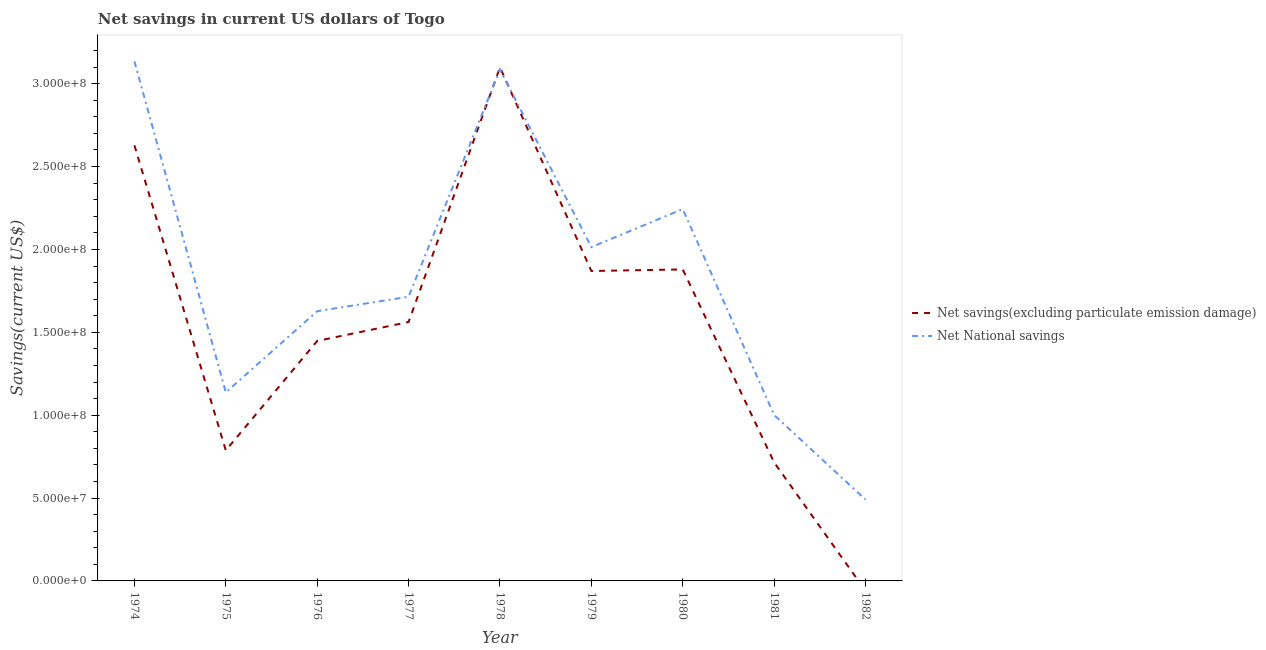What is the net national savings in 1976?
Ensure brevity in your answer.  1.63e+08. Across all years, what is the maximum net national savings?
Keep it short and to the point. 3.13e+08. Across all years, what is the minimum net savings(excluding particulate emission damage)?
Provide a succinct answer. 0. In which year was the net national savings maximum?
Offer a terse response. 1974. What is the total net national savings in the graph?
Your answer should be very brief. 1.64e+09. What is the difference between the net savings(excluding particulate emission damage) in 1974 and that in 1977?
Give a very brief answer. 1.07e+08. What is the difference between the net national savings in 1980 and the net savings(excluding particulate emission damage) in 1977?
Provide a succinct answer. 6.81e+07. What is the average net savings(excluding particulate emission damage) per year?
Provide a short and direct response. 1.55e+08. In the year 1974, what is the difference between the net savings(excluding particulate emission damage) and net national savings?
Your response must be concise. -5.07e+07. What is the ratio of the net national savings in 1976 to that in 1977?
Provide a short and direct response. 0.95. Is the net national savings in 1976 less than that in 1977?
Your response must be concise. Yes. What is the difference between the highest and the second highest net savings(excluding particulate emission damage)?
Your answer should be compact. 4.70e+07. What is the difference between the highest and the lowest net savings(excluding particulate emission damage)?
Provide a succinct answer. 3.10e+08. In how many years, is the net savings(excluding particulate emission damage) greater than the average net savings(excluding particulate emission damage) taken over all years?
Give a very brief answer. 5. Does the net national savings monotonically increase over the years?
Your response must be concise. No. Is the net national savings strictly greater than the net savings(excluding particulate emission damage) over the years?
Keep it short and to the point. No. How many lines are there?
Make the answer very short. 2. Are the values on the major ticks of Y-axis written in scientific E-notation?
Your answer should be very brief. Yes. Does the graph contain grids?
Offer a very short reply. No. How many legend labels are there?
Your answer should be compact. 2. How are the legend labels stacked?
Your answer should be very brief. Vertical. What is the title of the graph?
Offer a terse response. Net savings in current US dollars of Togo. Does "Mineral" appear as one of the legend labels in the graph?
Make the answer very short. No. What is the label or title of the X-axis?
Provide a short and direct response. Year. What is the label or title of the Y-axis?
Provide a succinct answer. Savings(current US$). What is the Savings(current US$) of Net savings(excluding particulate emission damage) in 1974?
Make the answer very short. 2.63e+08. What is the Savings(current US$) in Net National savings in 1974?
Ensure brevity in your answer.  3.13e+08. What is the Savings(current US$) in Net savings(excluding particulate emission damage) in 1975?
Make the answer very short. 7.87e+07. What is the Savings(current US$) in Net National savings in 1975?
Your answer should be very brief. 1.14e+08. What is the Savings(current US$) in Net savings(excluding particulate emission damage) in 1976?
Make the answer very short. 1.45e+08. What is the Savings(current US$) of Net National savings in 1976?
Your answer should be very brief. 1.63e+08. What is the Savings(current US$) of Net savings(excluding particulate emission damage) in 1977?
Make the answer very short. 1.56e+08. What is the Savings(current US$) in Net National savings in 1977?
Offer a very short reply. 1.71e+08. What is the Savings(current US$) in Net savings(excluding particulate emission damage) in 1978?
Provide a succinct answer. 3.10e+08. What is the Savings(current US$) of Net National savings in 1978?
Provide a succinct answer. 3.09e+08. What is the Savings(current US$) of Net savings(excluding particulate emission damage) in 1979?
Your answer should be very brief. 1.87e+08. What is the Savings(current US$) of Net National savings in 1979?
Provide a short and direct response. 2.01e+08. What is the Savings(current US$) of Net savings(excluding particulate emission damage) in 1980?
Your answer should be very brief. 1.88e+08. What is the Savings(current US$) of Net National savings in 1980?
Keep it short and to the point. 2.24e+08. What is the Savings(current US$) in Net savings(excluding particulate emission damage) in 1981?
Offer a terse response. 7.15e+07. What is the Savings(current US$) of Net National savings in 1981?
Your answer should be very brief. 1.00e+08. What is the Savings(current US$) in Net National savings in 1982?
Your answer should be compact. 4.91e+07. Across all years, what is the maximum Savings(current US$) in Net savings(excluding particulate emission damage)?
Keep it short and to the point. 3.10e+08. Across all years, what is the maximum Savings(current US$) of Net National savings?
Give a very brief answer. 3.13e+08. Across all years, what is the minimum Savings(current US$) of Net National savings?
Provide a short and direct response. 4.91e+07. What is the total Savings(current US$) in Net savings(excluding particulate emission damage) in the graph?
Your answer should be very brief. 1.40e+09. What is the total Savings(current US$) of Net National savings in the graph?
Provide a short and direct response. 1.64e+09. What is the difference between the Savings(current US$) in Net savings(excluding particulate emission damage) in 1974 and that in 1975?
Provide a succinct answer. 1.84e+08. What is the difference between the Savings(current US$) in Net National savings in 1974 and that in 1975?
Ensure brevity in your answer.  2.00e+08. What is the difference between the Savings(current US$) in Net savings(excluding particulate emission damage) in 1974 and that in 1976?
Offer a terse response. 1.18e+08. What is the difference between the Savings(current US$) in Net National savings in 1974 and that in 1976?
Offer a very short reply. 1.51e+08. What is the difference between the Savings(current US$) in Net savings(excluding particulate emission damage) in 1974 and that in 1977?
Offer a terse response. 1.07e+08. What is the difference between the Savings(current US$) of Net National savings in 1974 and that in 1977?
Your answer should be very brief. 1.42e+08. What is the difference between the Savings(current US$) in Net savings(excluding particulate emission damage) in 1974 and that in 1978?
Your response must be concise. -4.70e+07. What is the difference between the Savings(current US$) of Net National savings in 1974 and that in 1978?
Provide a succinct answer. 4.97e+06. What is the difference between the Savings(current US$) of Net savings(excluding particulate emission damage) in 1974 and that in 1979?
Your answer should be very brief. 7.58e+07. What is the difference between the Savings(current US$) in Net National savings in 1974 and that in 1979?
Provide a short and direct response. 1.12e+08. What is the difference between the Savings(current US$) in Net savings(excluding particulate emission damage) in 1974 and that in 1980?
Offer a very short reply. 7.49e+07. What is the difference between the Savings(current US$) in Net National savings in 1974 and that in 1980?
Ensure brevity in your answer.  8.91e+07. What is the difference between the Savings(current US$) of Net savings(excluding particulate emission damage) in 1974 and that in 1981?
Your response must be concise. 1.91e+08. What is the difference between the Savings(current US$) in Net National savings in 1974 and that in 1981?
Offer a very short reply. 2.13e+08. What is the difference between the Savings(current US$) of Net National savings in 1974 and that in 1982?
Your answer should be compact. 2.64e+08. What is the difference between the Savings(current US$) in Net savings(excluding particulate emission damage) in 1975 and that in 1976?
Keep it short and to the point. -6.61e+07. What is the difference between the Savings(current US$) of Net National savings in 1975 and that in 1976?
Your answer should be very brief. -4.90e+07. What is the difference between the Savings(current US$) of Net savings(excluding particulate emission damage) in 1975 and that in 1977?
Your answer should be very brief. -7.75e+07. What is the difference between the Savings(current US$) of Net National savings in 1975 and that in 1977?
Offer a terse response. -5.77e+07. What is the difference between the Savings(current US$) in Net savings(excluding particulate emission damage) in 1975 and that in 1978?
Give a very brief answer. -2.31e+08. What is the difference between the Savings(current US$) in Net National savings in 1975 and that in 1978?
Offer a very short reply. -1.95e+08. What is the difference between the Savings(current US$) in Net savings(excluding particulate emission damage) in 1975 and that in 1979?
Offer a terse response. -1.08e+08. What is the difference between the Savings(current US$) of Net National savings in 1975 and that in 1979?
Your answer should be very brief. -8.77e+07. What is the difference between the Savings(current US$) in Net savings(excluding particulate emission damage) in 1975 and that in 1980?
Your response must be concise. -1.09e+08. What is the difference between the Savings(current US$) in Net National savings in 1975 and that in 1980?
Offer a terse response. -1.11e+08. What is the difference between the Savings(current US$) of Net savings(excluding particulate emission damage) in 1975 and that in 1981?
Your answer should be very brief. 7.24e+06. What is the difference between the Savings(current US$) in Net National savings in 1975 and that in 1981?
Make the answer very short. 1.36e+07. What is the difference between the Savings(current US$) of Net National savings in 1975 and that in 1982?
Make the answer very short. 6.47e+07. What is the difference between the Savings(current US$) in Net savings(excluding particulate emission damage) in 1976 and that in 1977?
Offer a terse response. -1.14e+07. What is the difference between the Savings(current US$) of Net National savings in 1976 and that in 1977?
Provide a short and direct response. -8.74e+06. What is the difference between the Savings(current US$) in Net savings(excluding particulate emission damage) in 1976 and that in 1978?
Keep it short and to the point. -1.65e+08. What is the difference between the Savings(current US$) of Net National savings in 1976 and that in 1978?
Keep it short and to the point. -1.46e+08. What is the difference between the Savings(current US$) in Net savings(excluding particulate emission damage) in 1976 and that in 1979?
Give a very brief answer. -4.22e+07. What is the difference between the Savings(current US$) in Net National savings in 1976 and that in 1979?
Your answer should be compact. -3.87e+07. What is the difference between the Savings(current US$) in Net savings(excluding particulate emission damage) in 1976 and that in 1980?
Provide a short and direct response. -4.31e+07. What is the difference between the Savings(current US$) of Net National savings in 1976 and that in 1980?
Make the answer very short. -6.16e+07. What is the difference between the Savings(current US$) in Net savings(excluding particulate emission damage) in 1976 and that in 1981?
Offer a terse response. 7.33e+07. What is the difference between the Savings(current US$) of Net National savings in 1976 and that in 1981?
Keep it short and to the point. 6.26e+07. What is the difference between the Savings(current US$) of Net National savings in 1976 and that in 1982?
Provide a succinct answer. 1.14e+08. What is the difference between the Savings(current US$) of Net savings(excluding particulate emission damage) in 1977 and that in 1978?
Offer a terse response. -1.54e+08. What is the difference between the Savings(current US$) in Net National savings in 1977 and that in 1978?
Offer a terse response. -1.37e+08. What is the difference between the Savings(current US$) of Net savings(excluding particulate emission damage) in 1977 and that in 1979?
Provide a short and direct response. -3.08e+07. What is the difference between the Savings(current US$) of Net National savings in 1977 and that in 1979?
Provide a succinct answer. -2.99e+07. What is the difference between the Savings(current US$) of Net savings(excluding particulate emission damage) in 1977 and that in 1980?
Keep it short and to the point. -3.17e+07. What is the difference between the Savings(current US$) of Net National savings in 1977 and that in 1980?
Keep it short and to the point. -5.29e+07. What is the difference between the Savings(current US$) of Net savings(excluding particulate emission damage) in 1977 and that in 1981?
Offer a terse response. 8.47e+07. What is the difference between the Savings(current US$) of Net National savings in 1977 and that in 1981?
Make the answer very short. 7.14e+07. What is the difference between the Savings(current US$) of Net National savings in 1977 and that in 1982?
Offer a very short reply. 1.22e+08. What is the difference between the Savings(current US$) in Net savings(excluding particulate emission damage) in 1978 and that in 1979?
Keep it short and to the point. 1.23e+08. What is the difference between the Savings(current US$) of Net National savings in 1978 and that in 1979?
Your answer should be compact. 1.07e+08. What is the difference between the Savings(current US$) of Net savings(excluding particulate emission damage) in 1978 and that in 1980?
Provide a succinct answer. 1.22e+08. What is the difference between the Savings(current US$) in Net National savings in 1978 and that in 1980?
Make the answer very short. 8.42e+07. What is the difference between the Savings(current US$) in Net savings(excluding particulate emission damage) in 1978 and that in 1981?
Give a very brief answer. 2.38e+08. What is the difference between the Savings(current US$) in Net National savings in 1978 and that in 1981?
Keep it short and to the point. 2.08e+08. What is the difference between the Savings(current US$) in Net National savings in 1978 and that in 1982?
Offer a very short reply. 2.59e+08. What is the difference between the Savings(current US$) of Net savings(excluding particulate emission damage) in 1979 and that in 1980?
Your answer should be compact. -9.44e+05. What is the difference between the Savings(current US$) in Net National savings in 1979 and that in 1980?
Your response must be concise. -2.29e+07. What is the difference between the Savings(current US$) of Net savings(excluding particulate emission damage) in 1979 and that in 1981?
Offer a terse response. 1.15e+08. What is the difference between the Savings(current US$) in Net National savings in 1979 and that in 1981?
Ensure brevity in your answer.  1.01e+08. What is the difference between the Savings(current US$) in Net National savings in 1979 and that in 1982?
Keep it short and to the point. 1.52e+08. What is the difference between the Savings(current US$) of Net savings(excluding particulate emission damage) in 1980 and that in 1981?
Provide a succinct answer. 1.16e+08. What is the difference between the Savings(current US$) of Net National savings in 1980 and that in 1981?
Provide a succinct answer. 1.24e+08. What is the difference between the Savings(current US$) in Net National savings in 1980 and that in 1982?
Your answer should be very brief. 1.75e+08. What is the difference between the Savings(current US$) in Net National savings in 1981 and that in 1982?
Ensure brevity in your answer.  5.10e+07. What is the difference between the Savings(current US$) of Net savings(excluding particulate emission damage) in 1974 and the Savings(current US$) of Net National savings in 1975?
Give a very brief answer. 1.49e+08. What is the difference between the Savings(current US$) in Net savings(excluding particulate emission damage) in 1974 and the Savings(current US$) in Net National savings in 1976?
Give a very brief answer. 1.00e+08. What is the difference between the Savings(current US$) in Net savings(excluding particulate emission damage) in 1974 and the Savings(current US$) in Net National savings in 1977?
Your answer should be very brief. 9.13e+07. What is the difference between the Savings(current US$) of Net savings(excluding particulate emission damage) in 1974 and the Savings(current US$) of Net National savings in 1978?
Offer a very short reply. -4.57e+07. What is the difference between the Savings(current US$) in Net savings(excluding particulate emission damage) in 1974 and the Savings(current US$) in Net National savings in 1979?
Your answer should be very brief. 6.14e+07. What is the difference between the Savings(current US$) in Net savings(excluding particulate emission damage) in 1974 and the Savings(current US$) in Net National savings in 1980?
Make the answer very short. 3.85e+07. What is the difference between the Savings(current US$) of Net savings(excluding particulate emission damage) in 1974 and the Savings(current US$) of Net National savings in 1981?
Keep it short and to the point. 1.63e+08. What is the difference between the Savings(current US$) in Net savings(excluding particulate emission damage) in 1974 and the Savings(current US$) in Net National savings in 1982?
Provide a succinct answer. 2.14e+08. What is the difference between the Savings(current US$) of Net savings(excluding particulate emission damage) in 1975 and the Savings(current US$) of Net National savings in 1976?
Your answer should be compact. -8.40e+07. What is the difference between the Savings(current US$) of Net savings(excluding particulate emission damage) in 1975 and the Savings(current US$) of Net National savings in 1977?
Make the answer very short. -9.27e+07. What is the difference between the Savings(current US$) in Net savings(excluding particulate emission damage) in 1975 and the Savings(current US$) in Net National savings in 1978?
Your answer should be very brief. -2.30e+08. What is the difference between the Savings(current US$) in Net savings(excluding particulate emission damage) in 1975 and the Savings(current US$) in Net National savings in 1979?
Offer a terse response. -1.23e+08. What is the difference between the Savings(current US$) of Net savings(excluding particulate emission damage) in 1975 and the Savings(current US$) of Net National savings in 1980?
Offer a terse response. -1.46e+08. What is the difference between the Savings(current US$) in Net savings(excluding particulate emission damage) in 1975 and the Savings(current US$) in Net National savings in 1981?
Offer a terse response. -2.14e+07. What is the difference between the Savings(current US$) of Net savings(excluding particulate emission damage) in 1975 and the Savings(current US$) of Net National savings in 1982?
Give a very brief answer. 2.97e+07. What is the difference between the Savings(current US$) in Net savings(excluding particulate emission damage) in 1976 and the Savings(current US$) in Net National savings in 1977?
Your answer should be very brief. -2.67e+07. What is the difference between the Savings(current US$) in Net savings(excluding particulate emission damage) in 1976 and the Savings(current US$) in Net National savings in 1978?
Offer a very short reply. -1.64e+08. What is the difference between the Savings(current US$) of Net savings(excluding particulate emission damage) in 1976 and the Savings(current US$) of Net National savings in 1979?
Offer a very short reply. -5.66e+07. What is the difference between the Savings(current US$) of Net savings(excluding particulate emission damage) in 1976 and the Savings(current US$) of Net National savings in 1980?
Your answer should be very brief. -7.95e+07. What is the difference between the Savings(current US$) in Net savings(excluding particulate emission damage) in 1976 and the Savings(current US$) in Net National savings in 1981?
Your answer should be compact. 4.47e+07. What is the difference between the Savings(current US$) in Net savings(excluding particulate emission damage) in 1976 and the Savings(current US$) in Net National savings in 1982?
Provide a short and direct response. 9.57e+07. What is the difference between the Savings(current US$) in Net savings(excluding particulate emission damage) in 1977 and the Savings(current US$) in Net National savings in 1978?
Make the answer very short. -1.52e+08. What is the difference between the Savings(current US$) of Net savings(excluding particulate emission damage) in 1977 and the Savings(current US$) of Net National savings in 1979?
Your answer should be very brief. -4.52e+07. What is the difference between the Savings(current US$) in Net savings(excluding particulate emission damage) in 1977 and the Savings(current US$) in Net National savings in 1980?
Offer a terse response. -6.81e+07. What is the difference between the Savings(current US$) in Net savings(excluding particulate emission damage) in 1977 and the Savings(current US$) in Net National savings in 1981?
Your response must be concise. 5.61e+07. What is the difference between the Savings(current US$) in Net savings(excluding particulate emission damage) in 1977 and the Savings(current US$) in Net National savings in 1982?
Your response must be concise. 1.07e+08. What is the difference between the Savings(current US$) of Net savings(excluding particulate emission damage) in 1978 and the Savings(current US$) of Net National savings in 1979?
Keep it short and to the point. 1.08e+08. What is the difference between the Savings(current US$) in Net savings(excluding particulate emission damage) in 1978 and the Savings(current US$) in Net National savings in 1980?
Make the answer very short. 8.55e+07. What is the difference between the Savings(current US$) in Net savings(excluding particulate emission damage) in 1978 and the Savings(current US$) in Net National savings in 1981?
Offer a terse response. 2.10e+08. What is the difference between the Savings(current US$) of Net savings(excluding particulate emission damage) in 1978 and the Savings(current US$) of Net National savings in 1982?
Provide a succinct answer. 2.61e+08. What is the difference between the Savings(current US$) of Net savings(excluding particulate emission damage) in 1979 and the Savings(current US$) of Net National savings in 1980?
Give a very brief answer. -3.73e+07. What is the difference between the Savings(current US$) in Net savings(excluding particulate emission damage) in 1979 and the Savings(current US$) in Net National savings in 1981?
Ensure brevity in your answer.  8.69e+07. What is the difference between the Savings(current US$) in Net savings(excluding particulate emission damage) in 1979 and the Savings(current US$) in Net National savings in 1982?
Provide a succinct answer. 1.38e+08. What is the difference between the Savings(current US$) of Net savings(excluding particulate emission damage) in 1980 and the Savings(current US$) of Net National savings in 1981?
Offer a terse response. 8.78e+07. What is the difference between the Savings(current US$) in Net savings(excluding particulate emission damage) in 1980 and the Savings(current US$) in Net National savings in 1982?
Ensure brevity in your answer.  1.39e+08. What is the difference between the Savings(current US$) in Net savings(excluding particulate emission damage) in 1981 and the Savings(current US$) in Net National savings in 1982?
Give a very brief answer. 2.24e+07. What is the average Savings(current US$) in Net savings(excluding particulate emission damage) per year?
Give a very brief answer. 1.55e+08. What is the average Savings(current US$) of Net National savings per year?
Make the answer very short. 1.83e+08. In the year 1974, what is the difference between the Savings(current US$) of Net savings(excluding particulate emission damage) and Savings(current US$) of Net National savings?
Give a very brief answer. -5.07e+07. In the year 1975, what is the difference between the Savings(current US$) of Net savings(excluding particulate emission damage) and Savings(current US$) of Net National savings?
Your response must be concise. -3.50e+07. In the year 1976, what is the difference between the Savings(current US$) of Net savings(excluding particulate emission damage) and Savings(current US$) of Net National savings?
Give a very brief answer. -1.79e+07. In the year 1977, what is the difference between the Savings(current US$) of Net savings(excluding particulate emission damage) and Savings(current US$) of Net National savings?
Offer a very short reply. -1.53e+07. In the year 1978, what is the difference between the Savings(current US$) in Net savings(excluding particulate emission damage) and Savings(current US$) in Net National savings?
Provide a short and direct response. 1.35e+06. In the year 1979, what is the difference between the Savings(current US$) of Net savings(excluding particulate emission damage) and Savings(current US$) of Net National savings?
Your response must be concise. -1.44e+07. In the year 1980, what is the difference between the Savings(current US$) in Net savings(excluding particulate emission damage) and Savings(current US$) in Net National savings?
Offer a terse response. -3.64e+07. In the year 1981, what is the difference between the Savings(current US$) in Net savings(excluding particulate emission damage) and Savings(current US$) in Net National savings?
Your response must be concise. -2.86e+07. What is the ratio of the Savings(current US$) in Net savings(excluding particulate emission damage) in 1974 to that in 1975?
Ensure brevity in your answer.  3.34. What is the ratio of the Savings(current US$) of Net National savings in 1974 to that in 1975?
Your response must be concise. 2.76. What is the ratio of the Savings(current US$) in Net savings(excluding particulate emission damage) in 1974 to that in 1976?
Offer a terse response. 1.82. What is the ratio of the Savings(current US$) of Net National savings in 1974 to that in 1976?
Provide a succinct answer. 1.93. What is the ratio of the Savings(current US$) in Net savings(excluding particulate emission damage) in 1974 to that in 1977?
Offer a terse response. 1.68. What is the ratio of the Savings(current US$) in Net National savings in 1974 to that in 1977?
Your answer should be compact. 1.83. What is the ratio of the Savings(current US$) of Net savings(excluding particulate emission damage) in 1974 to that in 1978?
Offer a terse response. 0.85. What is the ratio of the Savings(current US$) of Net National savings in 1974 to that in 1978?
Offer a terse response. 1.02. What is the ratio of the Savings(current US$) of Net savings(excluding particulate emission damage) in 1974 to that in 1979?
Your answer should be very brief. 1.41. What is the ratio of the Savings(current US$) in Net National savings in 1974 to that in 1979?
Provide a short and direct response. 1.56. What is the ratio of the Savings(current US$) of Net savings(excluding particulate emission damage) in 1974 to that in 1980?
Ensure brevity in your answer.  1.4. What is the ratio of the Savings(current US$) of Net National savings in 1974 to that in 1980?
Make the answer very short. 1.4. What is the ratio of the Savings(current US$) in Net savings(excluding particulate emission damage) in 1974 to that in 1981?
Provide a succinct answer. 3.68. What is the ratio of the Savings(current US$) in Net National savings in 1974 to that in 1981?
Provide a short and direct response. 3.13. What is the ratio of the Savings(current US$) of Net National savings in 1974 to that in 1982?
Give a very brief answer. 6.39. What is the ratio of the Savings(current US$) of Net savings(excluding particulate emission damage) in 1975 to that in 1976?
Keep it short and to the point. 0.54. What is the ratio of the Savings(current US$) of Net National savings in 1975 to that in 1976?
Your response must be concise. 0.7. What is the ratio of the Savings(current US$) in Net savings(excluding particulate emission damage) in 1975 to that in 1977?
Ensure brevity in your answer.  0.5. What is the ratio of the Savings(current US$) in Net National savings in 1975 to that in 1977?
Your answer should be compact. 0.66. What is the ratio of the Savings(current US$) of Net savings(excluding particulate emission damage) in 1975 to that in 1978?
Your answer should be very brief. 0.25. What is the ratio of the Savings(current US$) in Net National savings in 1975 to that in 1978?
Your response must be concise. 0.37. What is the ratio of the Savings(current US$) in Net savings(excluding particulate emission damage) in 1975 to that in 1979?
Give a very brief answer. 0.42. What is the ratio of the Savings(current US$) in Net National savings in 1975 to that in 1979?
Provide a succinct answer. 0.56. What is the ratio of the Savings(current US$) in Net savings(excluding particulate emission damage) in 1975 to that in 1980?
Give a very brief answer. 0.42. What is the ratio of the Savings(current US$) of Net National savings in 1975 to that in 1980?
Your response must be concise. 0.51. What is the ratio of the Savings(current US$) in Net savings(excluding particulate emission damage) in 1975 to that in 1981?
Your answer should be very brief. 1.1. What is the ratio of the Savings(current US$) in Net National savings in 1975 to that in 1981?
Keep it short and to the point. 1.14. What is the ratio of the Savings(current US$) in Net National savings in 1975 to that in 1982?
Give a very brief answer. 2.32. What is the ratio of the Savings(current US$) of Net savings(excluding particulate emission damage) in 1976 to that in 1977?
Provide a short and direct response. 0.93. What is the ratio of the Savings(current US$) of Net National savings in 1976 to that in 1977?
Your answer should be compact. 0.95. What is the ratio of the Savings(current US$) of Net savings(excluding particulate emission damage) in 1976 to that in 1978?
Your answer should be very brief. 0.47. What is the ratio of the Savings(current US$) of Net National savings in 1976 to that in 1978?
Provide a short and direct response. 0.53. What is the ratio of the Savings(current US$) in Net savings(excluding particulate emission damage) in 1976 to that in 1979?
Provide a succinct answer. 0.77. What is the ratio of the Savings(current US$) of Net National savings in 1976 to that in 1979?
Your answer should be very brief. 0.81. What is the ratio of the Savings(current US$) of Net savings(excluding particulate emission damage) in 1976 to that in 1980?
Provide a succinct answer. 0.77. What is the ratio of the Savings(current US$) of Net National savings in 1976 to that in 1980?
Your answer should be very brief. 0.73. What is the ratio of the Savings(current US$) of Net savings(excluding particulate emission damage) in 1976 to that in 1981?
Your response must be concise. 2.03. What is the ratio of the Savings(current US$) in Net National savings in 1976 to that in 1981?
Your answer should be compact. 1.63. What is the ratio of the Savings(current US$) of Net National savings in 1976 to that in 1982?
Ensure brevity in your answer.  3.32. What is the ratio of the Savings(current US$) in Net savings(excluding particulate emission damage) in 1977 to that in 1978?
Ensure brevity in your answer.  0.5. What is the ratio of the Savings(current US$) of Net National savings in 1977 to that in 1978?
Ensure brevity in your answer.  0.56. What is the ratio of the Savings(current US$) in Net savings(excluding particulate emission damage) in 1977 to that in 1979?
Offer a terse response. 0.84. What is the ratio of the Savings(current US$) of Net National savings in 1977 to that in 1979?
Provide a succinct answer. 0.85. What is the ratio of the Savings(current US$) in Net savings(excluding particulate emission damage) in 1977 to that in 1980?
Offer a terse response. 0.83. What is the ratio of the Savings(current US$) of Net National savings in 1977 to that in 1980?
Offer a terse response. 0.76. What is the ratio of the Savings(current US$) in Net savings(excluding particulate emission damage) in 1977 to that in 1981?
Give a very brief answer. 2.18. What is the ratio of the Savings(current US$) of Net National savings in 1977 to that in 1981?
Your response must be concise. 1.71. What is the ratio of the Savings(current US$) in Net National savings in 1977 to that in 1982?
Your answer should be compact. 3.5. What is the ratio of the Savings(current US$) of Net savings(excluding particulate emission damage) in 1978 to that in 1979?
Ensure brevity in your answer.  1.66. What is the ratio of the Savings(current US$) of Net National savings in 1978 to that in 1979?
Offer a terse response. 1.53. What is the ratio of the Savings(current US$) in Net savings(excluding particulate emission damage) in 1978 to that in 1980?
Keep it short and to the point. 1.65. What is the ratio of the Savings(current US$) in Net National savings in 1978 to that in 1980?
Offer a terse response. 1.38. What is the ratio of the Savings(current US$) of Net savings(excluding particulate emission damage) in 1978 to that in 1981?
Your answer should be very brief. 4.33. What is the ratio of the Savings(current US$) of Net National savings in 1978 to that in 1981?
Give a very brief answer. 3.08. What is the ratio of the Savings(current US$) of Net National savings in 1978 to that in 1982?
Keep it short and to the point. 6.29. What is the ratio of the Savings(current US$) of Net savings(excluding particulate emission damage) in 1979 to that in 1980?
Provide a succinct answer. 0.99. What is the ratio of the Savings(current US$) in Net National savings in 1979 to that in 1980?
Make the answer very short. 0.9. What is the ratio of the Savings(current US$) in Net savings(excluding particulate emission damage) in 1979 to that in 1981?
Provide a short and direct response. 2.62. What is the ratio of the Savings(current US$) of Net National savings in 1979 to that in 1981?
Your response must be concise. 2.01. What is the ratio of the Savings(current US$) in Net National savings in 1979 to that in 1982?
Give a very brief answer. 4.11. What is the ratio of the Savings(current US$) in Net savings(excluding particulate emission damage) in 1980 to that in 1981?
Provide a succinct answer. 2.63. What is the ratio of the Savings(current US$) in Net National savings in 1980 to that in 1981?
Keep it short and to the point. 2.24. What is the ratio of the Savings(current US$) of Net National savings in 1980 to that in 1982?
Give a very brief answer. 4.57. What is the ratio of the Savings(current US$) in Net National savings in 1981 to that in 1982?
Keep it short and to the point. 2.04. What is the difference between the highest and the second highest Savings(current US$) in Net savings(excluding particulate emission damage)?
Provide a succinct answer. 4.70e+07. What is the difference between the highest and the second highest Savings(current US$) of Net National savings?
Ensure brevity in your answer.  4.97e+06. What is the difference between the highest and the lowest Savings(current US$) of Net savings(excluding particulate emission damage)?
Provide a short and direct response. 3.10e+08. What is the difference between the highest and the lowest Savings(current US$) of Net National savings?
Offer a very short reply. 2.64e+08. 